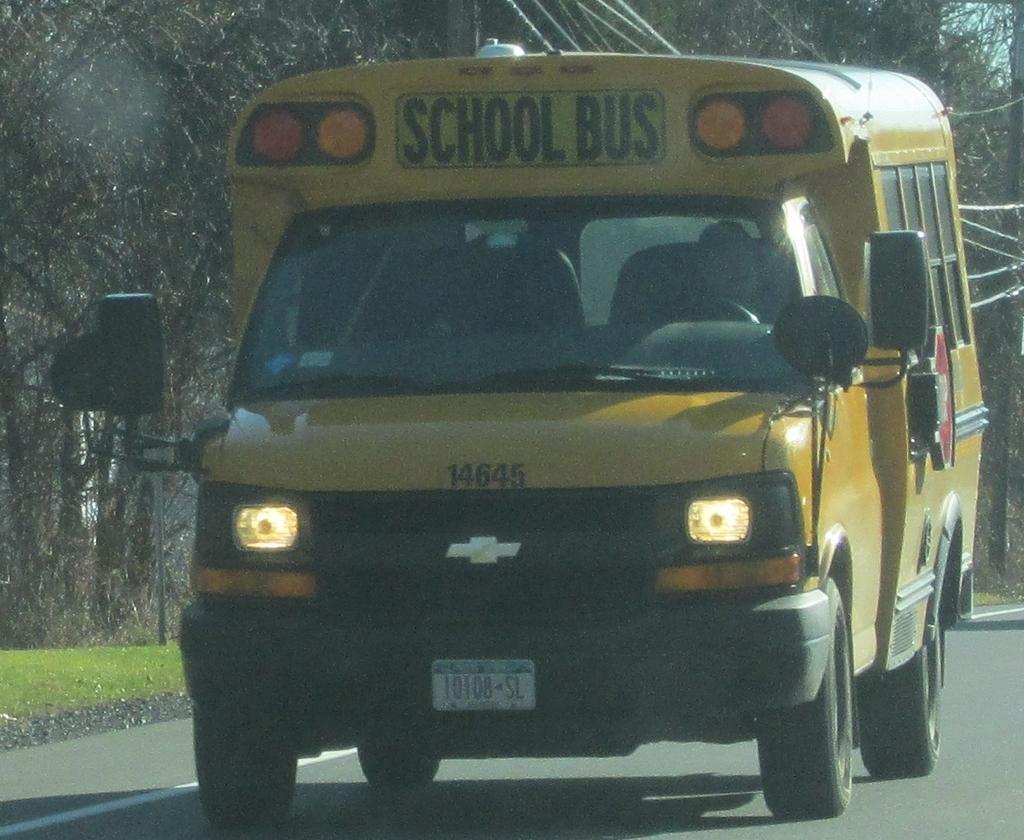In one or two sentences, can you explain what this image depicts? In the center of the pictures there is a bus, on the road. In the background there are trees, current pole, cables, gravel and grass. 